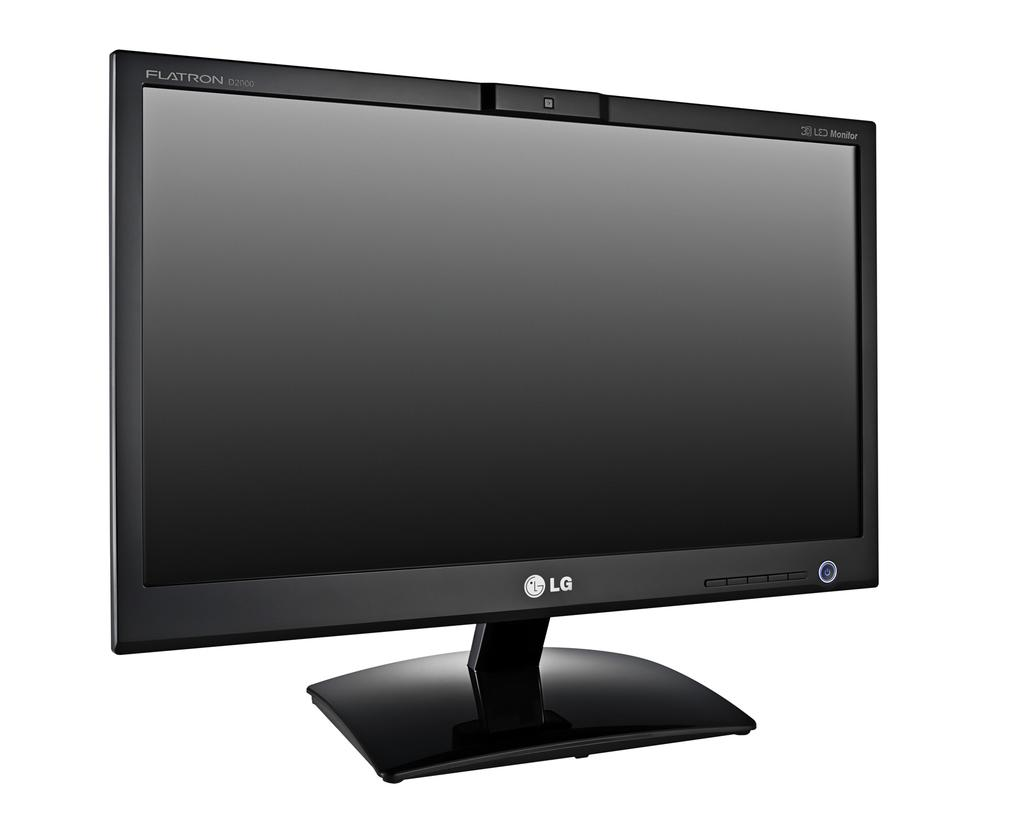Provide a one-sentence caption for the provided image. A black LG monitor with middle stand and center camera. 